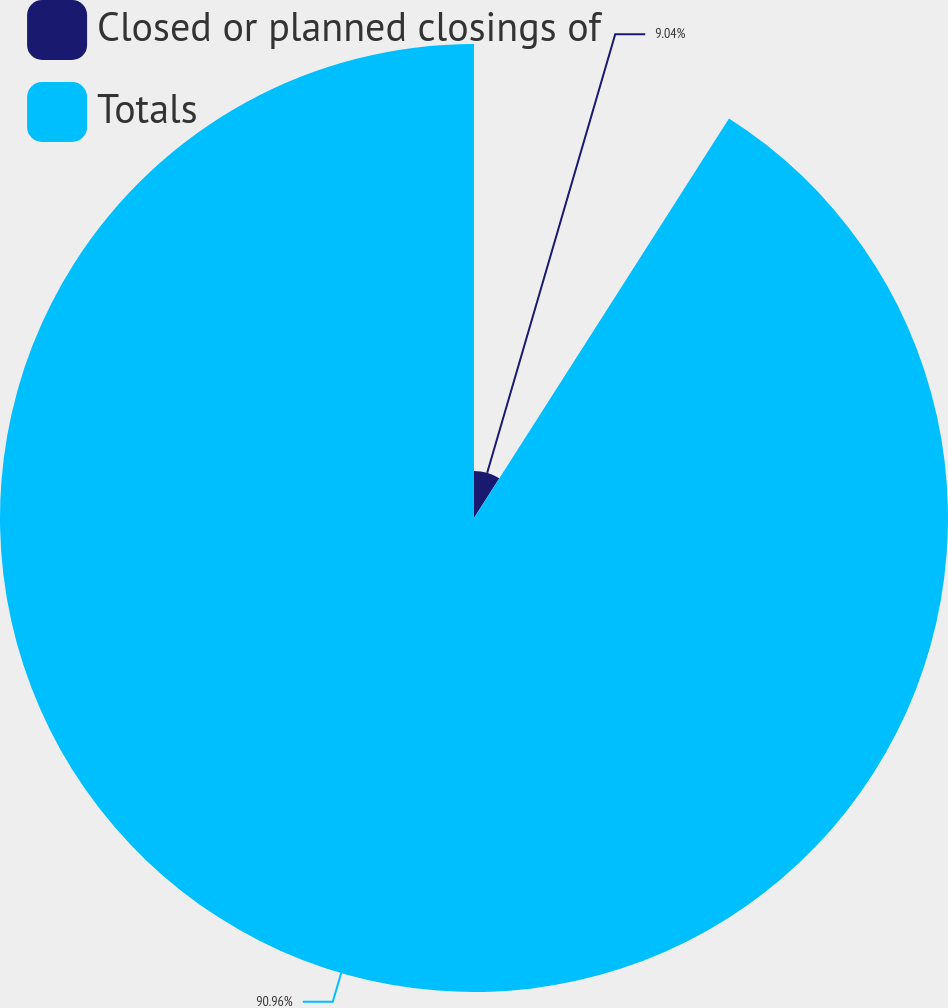Convert chart to OTSL. <chart><loc_0><loc_0><loc_500><loc_500><pie_chart><fcel>Closed or planned closings of<fcel>Totals<nl><fcel>9.04%<fcel>90.96%<nl></chart> 